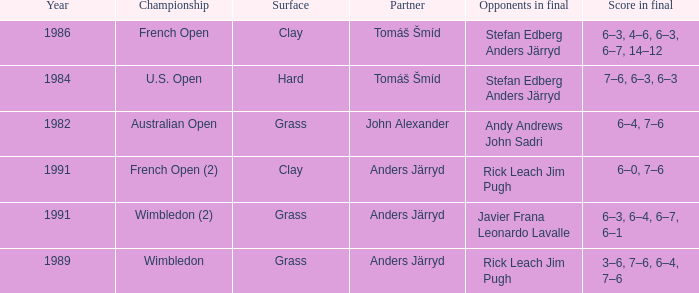Who was his partner in 1989?  Anders Järryd. 